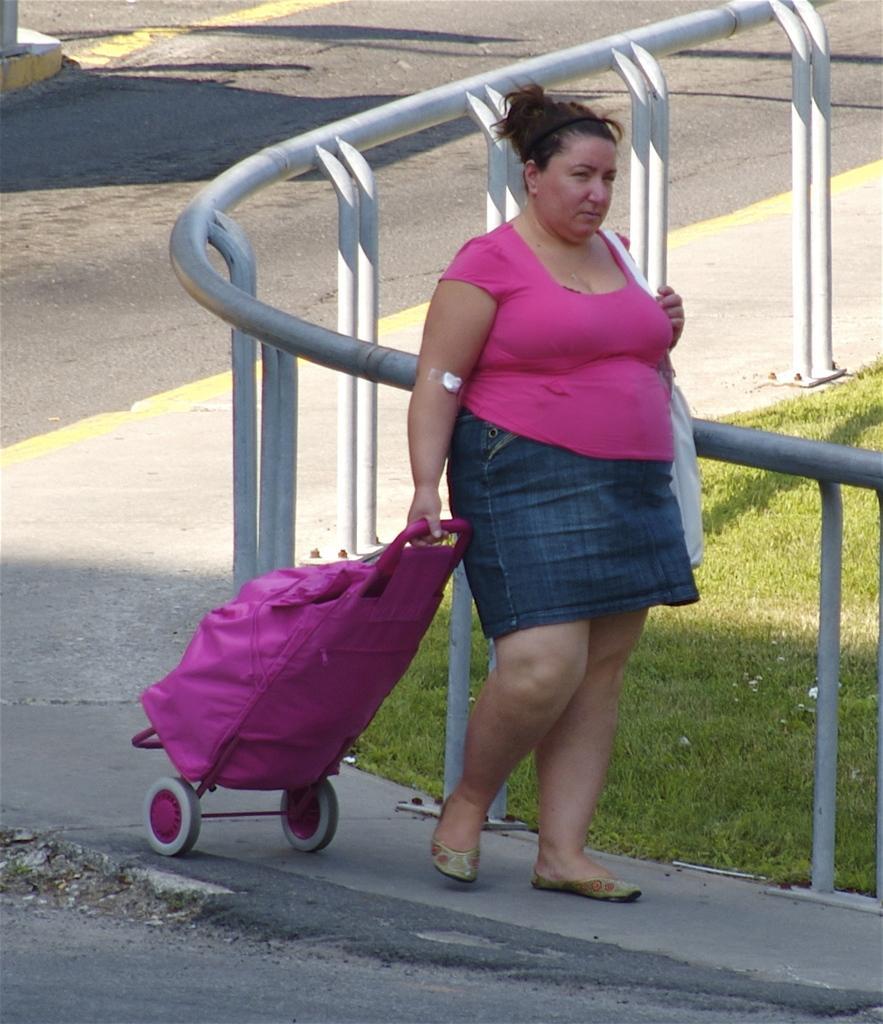In one or two sentences, can you explain what this image depicts? In this picture I can see a woman in front, who is on the path and I see that she is holding a pink color trolley and behind her I can see the railing and the grass. In the background I can see the road, on which there are yellow lines. 